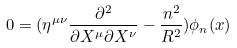Convert formula to latex. <formula><loc_0><loc_0><loc_500><loc_500>0 = ( \eta ^ { \mu \nu } \frac { \partial ^ { 2 } } { \partial X ^ { \mu } \partial X ^ { \nu } } - \frac { n ^ { 2 } } { R ^ { 2 } } ) \phi _ { n } ( x )</formula> 